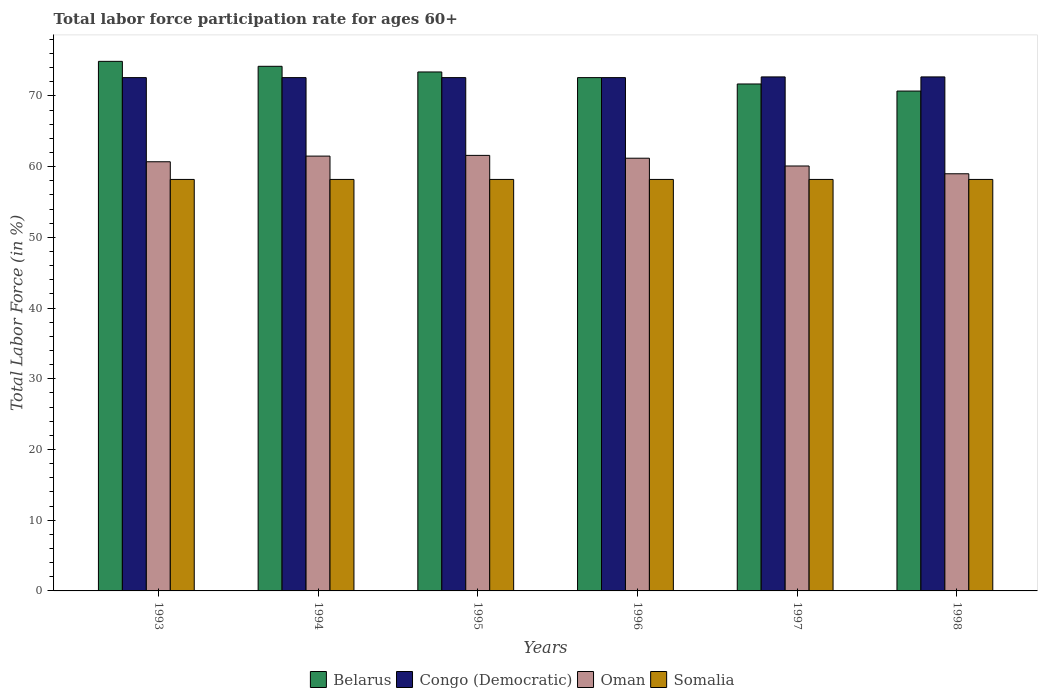How many groups of bars are there?
Your answer should be very brief. 6. How many bars are there on the 4th tick from the left?
Offer a very short reply. 4. In how many cases, is the number of bars for a given year not equal to the number of legend labels?
Ensure brevity in your answer.  0. What is the labor force participation rate in Belarus in 1995?
Offer a very short reply. 73.4. Across all years, what is the maximum labor force participation rate in Belarus?
Provide a succinct answer. 74.9. Across all years, what is the minimum labor force participation rate in Belarus?
Provide a short and direct response. 70.7. In which year was the labor force participation rate in Somalia minimum?
Your answer should be compact. 1993. What is the total labor force participation rate in Somalia in the graph?
Offer a terse response. 349.2. What is the difference between the labor force participation rate in Belarus in 1993 and that in 1998?
Provide a short and direct response. 4.2. What is the difference between the labor force participation rate in Oman in 1998 and the labor force participation rate in Somalia in 1996?
Make the answer very short. 0.8. What is the average labor force participation rate in Belarus per year?
Give a very brief answer. 72.92. In the year 1993, what is the difference between the labor force participation rate in Somalia and labor force participation rate in Congo (Democratic)?
Make the answer very short. -14.4. In how many years, is the labor force participation rate in Somalia greater than 50 %?
Your answer should be compact. 6. What is the difference between the highest and the second highest labor force participation rate in Congo (Democratic)?
Your answer should be very brief. 0. What is the difference between the highest and the lowest labor force participation rate in Congo (Democratic)?
Your answer should be compact. 0.1. Is the sum of the labor force participation rate in Belarus in 1993 and 1996 greater than the maximum labor force participation rate in Somalia across all years?
Your answer should be compact. Yes. Is it the case that in every year, the sum of the labor force participation rate in Congo (Democratic) and labor force participation rate in Somalia is greater than the sum of labor force participation rate in Belarus and labor force participation rate in Oman?
Your response must be concise. No. What does the 2nd bar from the left in 1994 represents?
Offer a very short reply. Congo (Democratic). What does the 3rd bar from the right in 1995 represents?
Your answer should be compact. Congo (Democratic). How many bars are there?
Ensure brevity in your answer.  24. How many legend labels are there?
Offer a very short reply. 4. What is the title of the graph?
Make the answer very short. Total labor force participation rate for ages 60+. Does "India" appear as one of the legend labels in the graph?
Keep it short and to the point. No. What is the label or title of the X-axis?
Keep it short and to the point. Years. What is the Total Labor Force (in %) of Belarus in 1993?
Your answer should be very brief. 74.9. What is the Total Labor Force (in %) of Congo (Democratic) in 1993?
Make the answer very short. 72.6. What is the Total Labor Force (in %) of Oman in 1993?
Your answer should be very brief. 60.7. What is the Total Labor Force (in %) of Somalia in 1993?
Offer a terse response. 58.2. What is the Total Labor Force (in %) in Belarus in 1994?
Ensure brevity in your answer.  74.2. What is the Total Labor Force (in %) in Congo (Democratic) in 1994?
Offer a very short reply. 72.6. What is the Total Labor Force (in %) in Oman in 1994?
Your response must be concise. 61.5. What is the Total Labor Force (in %) of Somalia in 1994?
Make the answer very short. 58.2. What is the Total Labor Force (in %) of Belarus in 1995?
Provide a succinct answer. 73.4. What is the Total Labor Force (in %) in Congo (Democratic) in 1995?
Ensure brevity in your answer.  72.6. What is the Total Labor Force (in %) of Oman in 1995?
Provide a succinct answer. 61.6. What is the Total Labor Force (in %) of Somalia in 1995?
Your answer should be compact. 58.2. What is the Total Labor Force (in %) of Belarus in 1996?
Offer a terse response. 72.6. What is the Total Labor Force (in %) in Congo (Democratic) in 1996?
Your answer should be compact. 72.6. What is the Total Labor Force (in %) in Oman in 1996?
Keep it short and to the point. 61.2. What is the Total Labor Force (in %) of Somalia in 1996?
Your answer should be compact. 58.2. What is the Total Labor Force (in %) in Belarus in 1997?
Offer a terse response. 71.7. What is the Total Labor Force (in %) of Congo (Democratic) in 1997?
Make the answer very short. 72.7. What is the Total Labor Force (in %) in Oman in 1997?
Your response must be concise. 60.1. What is the Total Labor Force (in %) of Somalia in 1997?
Provide a succinct answer. 58.2. What is the Total Labor Force (in %) in Belarus in 1998?
Offer a very short reply. 70.7. What is the Total Labor Force (in %) in Congo (Democratic) in 1998?
Provide a succinct answer. 72.7. What is the Total Labor Force (in %) of Somalia in 1998?
Ensure brevity in your answer.  58.2. Across all years, what is the maximum Total Labor Force (in %) in Belarus?
Your response must be concise. 74.9. Across all years, what is the maximum Total Labor Force (in %) of Congo (Democratic)?
Your response must be concise. 72.7. Across all years, what is the maximum Total Labor Force (in %) of Oman?
Offer a very short reply. 61.6. Across all years, what is the maximum Total Labor Force (in %) of Somalia?
Ensure brevity in your answer.  58.2. Across all years, what is the minimum Total Labor Force (in %) in Belarus?
Give a very brief answer. 70.7. Across all years, what is the minimum Total Labor Force (in %) of Congo (Democratic)?
Your answer should be compact. 72.6. Across all years, what is the minimum Total Labor Force (in %) of Somalia?
Your answer should be compact. 58.2. What is the total Total Labor Force (in %) in Belarus in the graph?
Ensure brevity in your answer.  437.5. What is the total Total Labor Force (in %) of Congo (Democratic) in the graph?
Offer a very short reply. 435.8. What is the total Total Labor Force (in %) of Oman in the graph?
Your answer should be compact. 364.1. What is the total Total Labor Force (in %) in Somalia in the graph?
Your response must be concise. 349.2. What is the difference between the Total Labor Force (in %) in Belarus in 1993 and that in 1994?
Provide a short and direct response. 0.7. What is the difference between the Total Labor Force (in %) in Oman in 1993 and that in 1995?
Your answer should be compact. -0.9. What is the difference between the Total Labor Force (in %) in Somalia in 1993 and that in 1995?
Keep it short and to the point. 0. What is the difference between the Total Labor Force (in %) in Belarus in 1993 and that in 1996?
Your response must be concise. 2.3. What is the difference between the Total Labor Force (in %) of Somalia in 1993 and that in 1996?
Keep it short and to the point. 0. What is the difference between the Total Labor Force (in %) of Belarus in 1993 and that in 1997?
Provide a short and direct response. 3.2. What is the difference between the Total Labor Force (in %) in Oman in 1993 and that in 1997?
Provide a succinct answer. 0.6. What is the difference between the Total Labor Force (in %) of Somalia in 1993 and that in 1997?
Your answer should be compact. 0. What is the difference between the Total Labor Force (in %) of Belarus in 1993 and that in 1998?
Make the answer very short. 4.2. What is the difference between the Total Labor Force (in %) of Oman in 1993 and that in 1998?
Provide a short and direct response. 1.7. What is the difference between the Total Labor Force (in %) of Somalia in 1993 and that in 1998?
Offer a very short reply. 0. What is the difference between the Total Labor Force (in %) in Belarus in 1994 and that in 1996?
Make the answer very short. 1.6. What is the difference between the Total Labor Force (in %) of Congo (Democratic) in 1994 and that in 1996?
Your answer should be compact. 0. What is the difference between the Total Labor Force (in %) of Somalia in 1994 and that in 1996?
Provide a succinct answer. 0. What is the difference between the Total Labor Force (in %) in Belarus in 1994 and that in 1997?
Your answer should be compact. 2.5. What is the difference between the Total Labor Force (in %) of Congo (Democratic) in 1994 and that in 1998?
Ensure brevity in your answer.  -0.1. What is the difference between the Total Labor Force (in %) of Somalia in 1994 and that in 1998?
Offer a very short reply. 0. What is the difference between the Total Labor Force (in %) in Belarus in 1995 and that in 1996?
Provide a short and direct response. 0.8. What is the difference between the Total Labor Force (in %) of Somalia in 1995 and that in 1996?
Offer a terse response. 0. What is the difference between the Total Labor Force (in %) of Belarus in 1995 and that in 1997?
Give a very brief answer. 1.7. What is the difference between the Total Labor Force (in %) of Oman in 1995 and that in 1997?
Provide a succinct answer. 1.5. What is the difference between the Total Labor Force (in %) in Congo (Democratic) in 1995 and that in 1998?
Ensure brevity in your answer.  -0.1. What is the difference between the Total Labor Force (in %) in Oman in 1995 and that in 1998?
Your answer should be compact. 2.6. What is the difference between the Total Labor Force (in %) in Congo (Democratic) in 1996 and that in 1997?
Offer a very short reply. -0.1. What is the difference between the Total Labor Force (in %) of Somalia in 1996 and that in 1997?
Offer a terse response. 0. What is the difference between the Total Labor Force (in %) of Belarus in 1996 and that in 1998?
Provide a short and direct response. 1.9. What is the difference between the Total Labor Force (in %) of Oman in 1996 and that in 1998?
Your response must be concise. 2.2. What is the difference between the Total Labor Force (in %) of Somalia in 1996 and that in 1998?
Your answer should be compact. 0. What is the difference between the Total Labor Force (in %) in Belarus in 1997 and that in 1998?
Your answer should be compact. 1. What is the difference between the Total Labor Force (in %) of Oman in 1997 and that in 1998?
Your answer should be very brief. 1.1. What is the difference between the Total Labor Force (in %) in Belarus in 1993 and the Total Labor Force (in %) in Oman in 1994?
Ensure brevity in your answer.  13.4. What is the difference between the Total Labor Force (in %) of Belarus in 1993 and the Total Labor Force (in %) of Somalia in 1994?
Ensure brevity in your answer.  16.7. What is the difference between the Total Labor Force (in %) of Congo (Democratic) in 1993 and the Total Labor Force (in %) of Oman in 1994?
Make the answer very short. 11.1. What is the difference between the Total Labor Force (in %) of Congo (Democratic) in 1993 and the Total Labor Force (in %) of Somalia in 1994?
Keep it short and to the point. 14.4. What is the difference between the Total Labor Force (in %) of Oman in 1993 and the Total Labor Force (in %) of Somalia in 1994?
Ensure brevity in your answer.  2.5. What is the difference between the Total Labor Force (in %) of Belarus in 1993 and the Total Labor Force (in %) of Somalia in 1995?
Ensure brevity in your answer.  16.7. What is the difference between the Total Labor Force (in %) in Belarus in 1993 and the Total Labor Force (in %) in Oman in 1996?
Keep it short and to the point. 13.7. What is the difference between the Total Labor Force (in %) of Congo (Democratic) in 1993 and the Total Labor Force (in %) of Oman in 1996?
Offer a terse response. 11.4. What is the difference between the Total Labor Force (in %) in Congo (Democratic) in 1993 and the Total Labor Force (in %) in Somalia in 1996?
Offer a terse response. 14.4. What is the difference between the Total Labor Force (in %) of Belarus in 1993 and the Total Labor Force (in %) of Somalia in 1997?
Provide a succinct answer. 16.7. What is the difference between the Total Labor Force (in %) of Congo (Democratic) in 1993 and the Total Labor Force (in %) of Oman in 1997?
Provide a short and direct response. 12.5. What is the difference between the Total Labor Force (in %) of Congo (Democratic) in 1993 and the Total Labor Force (in %) of Somalia in 1997?
Your response must be concise. 14.4. What is the difference between the Total Labor Force (in %) in Oman in 1993 and the Total Labor Force (in %) in Somalia in 1997?
Ensure brevity in your answer.  2.5. What is the difference between the Total Labor Force (in %) in Belarus in 1993 and the Total Labor Force (in %) in Somalia in 1998?
Keep it short and to the point. 16.7. What is the difference between the Total Labor Force (in %) in Oman in 1993 and the Total Labor Force (in %) in Somalia in 1998?
Make the answer very short. 2.5. What is the difference between the Total Labor Force (in %) in Belarus in 1994 and the Total Labor Force (in %) in Oman in 1995?
Provide a succinct answer. 12.6. What is the difference between the Total Labor Force (in %) in Belarus in 1994 and the Total Labor Force (in %) in Somalia in 1995?
Offer a very short reply. 16. What is the difference between the Total Labor Force (in %) of Congo (Democratic) in 1994 and the Total Labor Force (in %) of Somalia in 1995?
Make the answer very short. 14.4. What is the difference between the Total Labor Force (in %) of Oman in 1994 and the Total Labor Force (in %) of Somalia in 1995?
Your response must be concise. 3.3. What is the difference between the Total Labor Force (in %) of Belarus in 1994 and the Total Labor Force (in %) of Congo (Democratic) in 1996?
Provide a short and direct response. 1.6. What is the difference between the Total Labor Force (in %) of Belarus in 1994 and the Total Labor Force (in %) of Somalia in 1996?
Offer a terse response. 16. What is the difference between the Total Labor Force (in %) of Congo (Democratic) in 1994 and the Total Labor Force (in %) of Oman in 1996?
Provide a short and direct response. 11.4. What is the difference between the Total Labor Force (in %) of Congo (Democratic) in 1994 and the Total Labor Force (in %) of Somalia in 1996?
Provide a succinct answer. 14.4. What is the difference between the Total Labor Force (in %) in Belarus in 1994 and the Total Labor Force (in %) in Congo (Democratic) in 1997?
Your answer should be very brief. 1.5. What is the difference between the Total Labor Force (in %) of Belarus in 1994 and the Total Labor Force (in %) of Oman in 1997?
Provide a succinct answer. 14.1. What is the difference between the Total Labor Force (in %) in Belarus in 1994 and the Total Labor Force (in %) in Somalia in 1997?
Offer a terse response. 16. What is the difference between the Total Labor Force (in %) of Congo (Democratic) in 1994 and the Total Labor Force (in %) of Somalia in 1997?
Offer a very short reply. 14.4. What is the difference between the Total Labor Force (in %) in Belarus in 1994 and the Total Labor Force (in %) in Oman in 1998?
Your response must be concise. 15.2. What is the difference between the Total Labor Force (in %) of Belarus in 1995 and the Total Labor Force (in %) of Congo (Democratic) in 1996?
Your response must be concise. 0.8. What is the difference between the Total Labor Force (in %) in Belarus in 1995 and the Total Labor Force (in %) in Oman in 1996?
Offer a very short reply. 12.2. What is the difference between the Total Labor Force (in %) in Congo (Democratic) in 1995 and the Total Labor Force (in %) in Oman in 1996?
Your answer should be compact. 11.4. What is the difference between the Total Labor Force (in %) of Oman in 1995 and the Total Labor Force (in %) of Somalia in 1996?
Make the answer very short. 3.4. What is the difference between the Total Labor Force (in %) of Belarus in 1995 and the Total Labor Force (in %) of Oman in 1997?
Your answer should be compact. 13.3. What is the difference between the Total Labor Force (in %) in Congo (Democratic) in 1995 and the Total Labor Force (in %) in Oman in 1997?
Make the answer very short. 12.5. What is the difference between the Total Labor Force (in %) of Oman in 1995 and the Total Labor Force (in %) of Somalia in 1997?
Give a very brief answer. 3.4. What is the difference between the Total Labor Force (in %) of Belarus in 1996 and the Total Labor Force (in %) of Congo (Democratic) in 1997?
Provide a succinct answer. -0.1. What is the difference between the Total Labor Force (in %) of Belarus in 1996 and the Total Labor Force (in %) of Oman in 1997?
Your answer should be very brief. 12.5. What is the difference between the Total Labor Force (in %) in Congo (Democratic) in 1996 and the Total Labor Force (in %) in Oman in 1997?
Provide a succinct answer. 12.5. What is the difference between the Total Labor Force (in %) of Belarus in 1996 and the Total Labor Force (in %) of Oman in 1998?
Offer a terse response. 13.6. What is the difference between the Total Labor Force (in %) of Congo (Democratic) in 1996 and the Total Labor Force (in %) of Oman in 1998?
Ensure brevity in your answer.  13.6. What is the difference between the Total Labor Force (in %) of Congo (Democratic) in 1996 and the Total Labor Force (in %) of Somalia in 1998?
Keep it short and to the point. 14.4. What is the difference between the Total Labor Force (in %) of Belarus in 1997 and the Total Labor Force (in %) of Congo (Democratic) in 1998?
Offer a terse response. -1. What is the average Total Labor Force (in %) of Belarus per year?
Make the answer very short. 72.92. What is the average Total Labor Force (in %) in Congo (Democratic) per year?
Your answer should be very brief. 72.63. What is the average Total Labor Force (in %) of Oman per year?
Provide a short and direct response. 60.68. What is the average Total Labor Force (in %) of Somalia per year?
Your response must be concise. 58.2. In the year 1993, what is the difference between the Total Labor Force (in %) in Belarus and Total Labor Force (in %) in Congo (Democratic)?
Ensure brevity in your answer.  2.3. In the year 1993, what is the difference between the Total Labor Force (in %) in Belarus and Total Labor Force (in %) in Oman?
Make the answer very short. 14.2. In the year 1993, what is the difference between the Total Labor Force (in %) of Belarus and Total Labor Force (in %) of Somalia?
Provide a succinct answer. 16.7. In the year 1993, what is the difference between the Total Labor Force (in %) of Congo (Democratic) and Total Labor Force (in %) of Oman?
Offer a terse response. 11.9. In the year 1994, what is the difference between the Total Labor Force (in %) in Belarus and Total Labor Force (in %) in Congo (Democratic)?
Give a very brief answer. 1.6. In the year 1994, what is the difference between the Total Labor Force (in %) in Belarus and Total Labor Force (in %) in Oman?
Your response must be concise. 12.7. In the year 1994, what is the difference between the Total Labor Force (in %) in Belarus and Total Labor Force (in %) in Somalia?
Offer a terse response. 16. In the year 1994, what is the difference between the Total Labor Force (in %) in Congo (Democratic) and Total Labor Force (in %) in Oman?
Provide a short and direct response. 11.1. In the year 1994, what is the difference between the Total Labor Force (in %) in Oman and Total Labor Force (in %) in Somalia?
Your response must be concise. 3.3. In the year 1995, what is the difference between the Total Labor Force (in %) of Belarus and Total Labor Force (in %) of Oman?
Give a very brief answer. 11.8. In the year 1995, what is the difference between the Total Labor Force (in %) of Oman and Total Labor Force (in %) of Somalia?
Provide a succinct answer. 3.4. In the year 1996, what is the difference between the Total Labor Force (in %) of Belarus and Total Labor Force (in %) of Oman?
Your answer should be compact. 11.4. In the year 1997, what is the difference between the Total Labor Force (in %) in Congo (Democratic) and Total Labor Force (in %) in Oman?
Provide a short and direct response. 12.6. In the year 1997, what is the difference between the Total Labor Force (in %) in Oman and Total Labor Force (in %) in Somalia?
Ensure brevity in your answer.  1.9. In the year 1998, what is the difference between the Total Labor Force (in %) in Belarus and Total Labor Force (in %) in Congo (Democratic)?
Ensure brevity in your answer.  -2. In the year 1998, what is the difference between the Total Labor Force (in %) of Belarus and Total Labor Force (in %) of Oman?
Provide a succinct answer. 11.7. What is the ratio of the Total Labor Force (in %) of Belarus in 1993 to that in 1994?
Offer a very short reply. 1.01. What is the ratio of the Total Labor Force (in %) of Congo (Democratic) in 1993 to that in 1994?
Your answer should be very brief. 1. What is the ratio of the Total Labor Force (in %) in Oman in 1993 to that in 1994?
Offer a terse response. 0.99. What is the ratio of the Total Labor Force (in %) in Somalia in 1993 to that in 1994?
Provide a short and direct response. 1. What is the ratio of the Total Labor Force (in %) of Belarus in 1993 to that in 1995?
Offer a terse response. 1.02. What is the ratio of the Total Labor Force (in %) of Oman in 1993 to that in 1995?
Make the answer very short. 0.99. What is the ratio of the Total Labor Force (in %) in Somalia in 1993 to that in 1995?
Your answer should be very brief. 1. What is the ratio of the Total Labor Force (in %) in Belarus in 1993 to that in 1996?
Give a very brief answer. 1.03. What is the ratio of the Total Labor Force (in %) in Congo (Democratic) in 1993 to that in 1996?
Your response must be concise. 1. What is the ratio of the Total Labor Force (in %) of Belarus in 1993 to that in 1997?
Give a very brief answer. 1.04. What is the ratio of the Total Labor Force (in %) in Congo (Democratic) in 1993 to that in 1997?
Give a very brief answer. 1. What is the ratio of the Total Labor Force (in %) of Oman in 1993 to that in 1997?
Provide a succinct answer. 1.01. What is the ratio of the Total Labor Force (in %) in Somalia in 1993 to that in 1997?
Ensure brevity in your answer.  1. What is the ratio of the Total Labor Force (in %) in Belarus in 1993 to that in 1998?
Offer a terse response. 1.06. What is the ratio of the Total Labor Force (in %) of Oman in 1993 to that in 1998?
Keep it short and to the point. 1.03. What is the ratio of the Total Labor Force (in %) of Somalia in 1993 to that in 1998?
Offer a terse response. 1. What is the ratio of the Total Labor Force (in %) of Belarus in 1994 to that in 1995?
Provide a succinct answer. 1.01. What is the ratio of the Total Labor Force (in %) of Somalia in 1994 to that in 1995?
Provide a succinct answer. 1. What is the ratio of the Total Labor Force (in %) of Belarus in 1994 to that in 1996?
Offer a very short reply. 1.02. What is the ratio of the Total Labor Force (in %) of Congo (Democratic) in 1994 to that in 1996?
Ensure brevity in your answer.  1. What is the ratio of the Total Labor Force (in %) of Oman in 1994 to that in 1996?
Provide a short and direct response. 1. What is the ratio of the Total Labor Force (in %) in Somalia in 1994 to that in 1996?
Offer a very short reply. 1. What is the ratio of the Total Labor Force (in %) of Belarus in 1994 to that in 1997?
Provide a succinct answer. 1.03. What is the ratio of the Total Labor Force (in %) in Oman in 1994 to that in 1997?
Make the answer very short. 1.02. What is the ratio of the Total Labor Force (in %) in Somalia in 1994 to that in 1997?
Ensure brevity in your answer.  1. What is the ratio of the Total Labor Force (in %) of Belarus in 1994 to that in 1998?
Provide a short and direct response. 1.05. What is the ratio of the Total Labor Force (in %) of Congo (Democratic) in 1994 to that in 1998?
Make the answer very short. 1. What is the ratio of the Total Labor Force (in %) in Oman in 1994 to that in 1998?
Provide a short and direct response. 1.04. What is the ratio of the Total Labor Force (in %) of Congo (Democratic) in 1995 to that in 1996?
Make the answer very short. 1. What is the ratio of the Total Labor Force (in %) of Somalia in 1995 to that in 1996?
Ensure brevity in your answer.  1. What is the ratio of the Total Labor Force (in %) of Belarus in 1995 to that in 1997?
Make the answer very short. 1.02. What is the ratio of the Total Labor Force (in %) of Congo (Democratic) in 1995 to that in 1997?
Give a very brief answer. 1. What is the ratio of the Total Labor Force (in %) in Oman in 1995 to that in 1997?
Offer a terse response. 1.02. What is the ratio of the Total Labor Force (in %) of Belarus in 1995 to that in 1998?
Your response must be concise. 1.04. What is the ratio of the Total Labor Force (in %) in Congo (Democratic) in 1995 to that in 1998?
Keep it short and to the point. 1. What is the ratio of the Total Labor Force (in %) of Oman in 1995 to that in 1998?
Offer a very short reply. 1.04. What is the ratio of the Total Labor Force (in %) in Belarus in 1996 to that in 1997?
Ensure brevity in your answer.  1.01. What is the ratio of the Total Labor Force (in %) of Congo (Democratic) in 1996 to that in 1997?
Offer a terse response. 1. What is the ratio of the Total Labor Force (in %) of Oman in 1996 to that in 1997?
Your answer should be compact. 1.02. What is the ratio of the Total Labor Force (in %) of Belarus in 1996 to that in 1998?
Provide a succinct answer. 1.03. What is the ratio of the Total Labor Force (in %) in Congo (Democratic) in 1996 to that in 1998?
Make the answer very short. 1. What is the ratio of the Total Labor Force (in %) in Oman in 1996 to that in 1998?
Offer a terse response. 1.04. What is the ratio of the Total Labor Force (in %) of Somalia in 1996 to that in 1998?
Provide a succinct answer. 1. What is the ratio of the Total Labor Force (in %) of Belarus in 1997 to that in 1998?
Offer a terse response. 1.01. What is the ratio of the Total Labor Force (in %) in Congo (Democratic) in 1997 to that in 1998?
Offer a terse response. 1. What is the ratio of the Total Labor Force (in %) in Oman in 1997 to that in 1998?
Offer a terse response. 1.02. What is the difference between the highest and the second highest Total Labor Force (in %) of Oman?
Offer a very short reply. 0.1. What is the difference between the highest and the second highest Total Labor Force (in %) in Somalia?
Make the answer very short. 0. What is the difference between the highest and the lowest Total Labor Force (in %) of Oman?
Ensure brevity in your answer.  2.6. What is the difference between the highest and the lowest Total Labor Force (in %) of Somalia?
Ensure brevity in your answer.  0. 